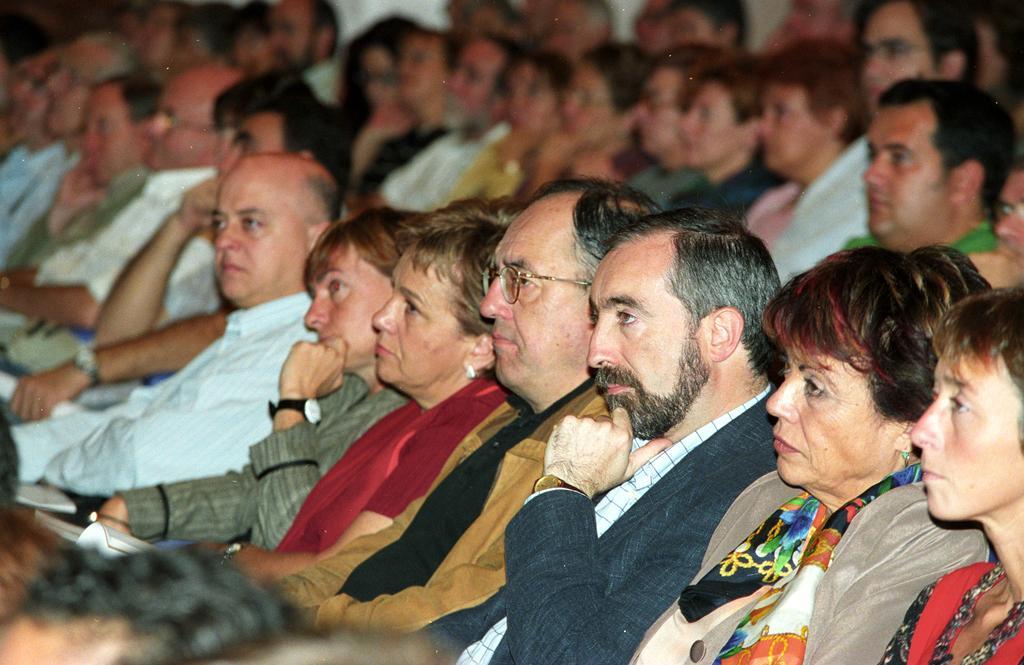In one or two sentences, can you explain what this image depicts? In this image we can see group of people. 